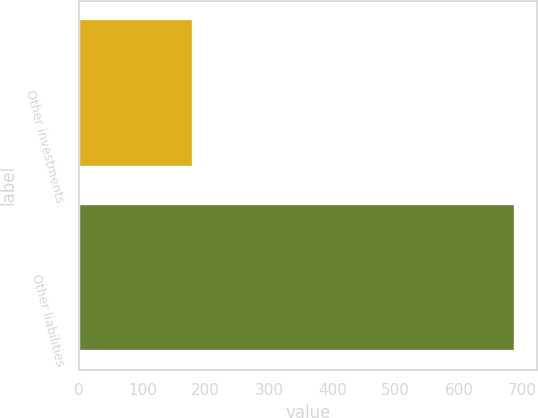<chart> <loc_0><loc_0><loc_500><loc_500><bar_chart><fcel>Other investments<fcel>Other liabilities<nl><fcel>180<fcel>689<nl></chart> 